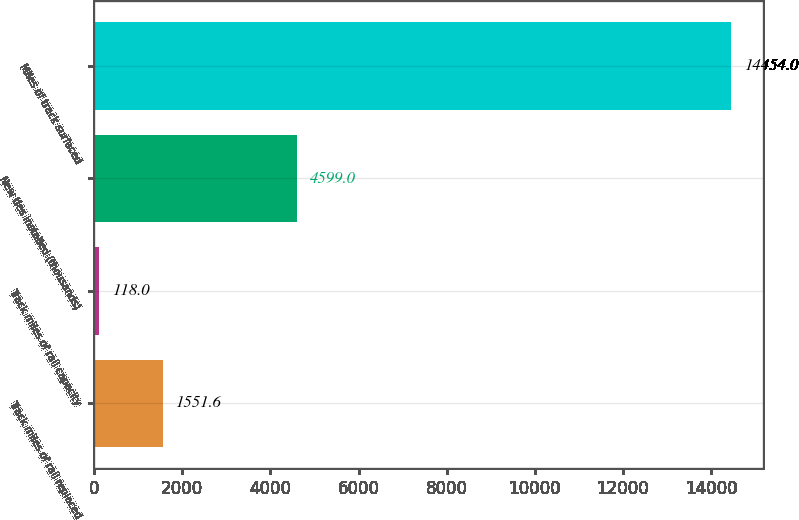Convert chart. <chart><loc_0><loc_0><loc_500><loc_500><bar_chart><fcel>Track miles of rail replaced<fcel>Track miles of rail capacity<fcel>New ties installed (thousands)<fcel>Miles of track surfaced<nl><fcel>1551.6<fcel>118<fcel>4599<fcel>14454<nl></chart> 